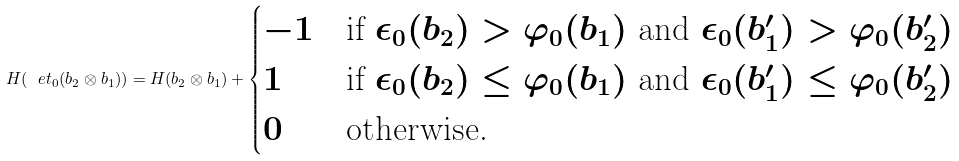<formula> <loc_0><loc_0><loc_500><loc_500>H ( \ e t _ { 0 } ( b _ { 2 } \otimes b _ { 1 } ) ) = H ( b _ { 2 } \otimes b _ { 1 } ) + \begin{cases} - 1 & \text {if $\epsilon_{0}(b_{2})>\varphi_{0}(b_{1})$ and   $\epsilon_{0}(b_{1}^{\prime})>\varphi_{0}(b_{2}^{\prime})$} \\ 1 & \text {if $\epsilon_{0}(b_{2})\leq\varphi_{0}(b_{1})$ and   $\epsilon_{0}(b_{1}^{\prime})\leq \varphi_{0}(b_{2}^{\prime})$} \\ 0 & \text {otherwise.} \end{cases}</formula> 